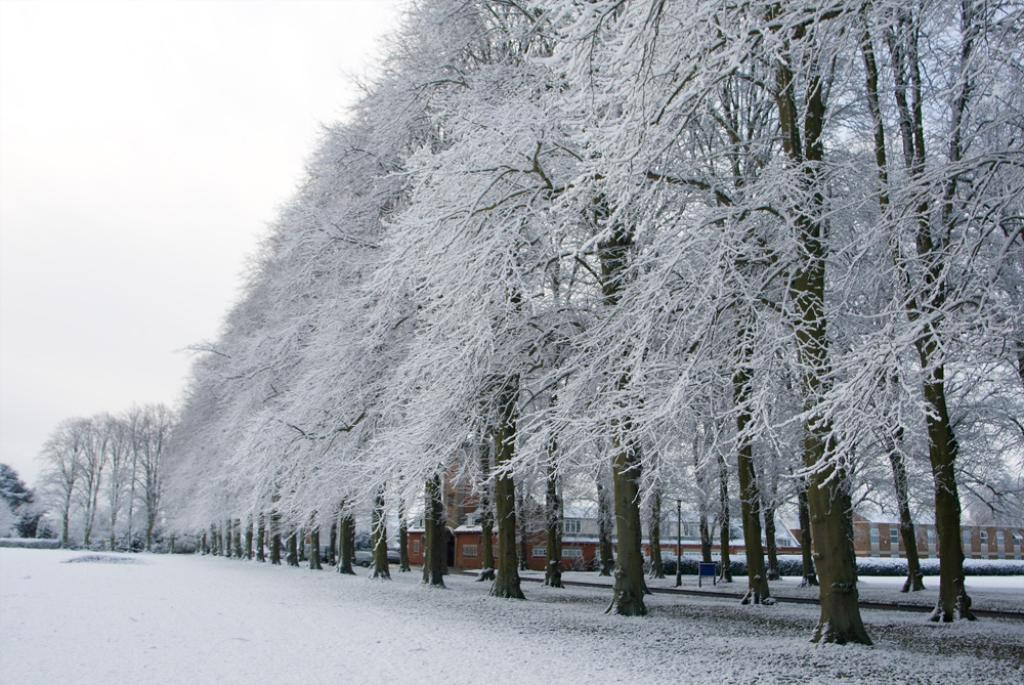What type of vegetation is present in the image? There are trees in the image. What is covering the ground in the image? There is snow in the image. What type of structures can be seen in the image? There are buildings with windows in the image. What else can be seen in the image besides trees and buildings? There are objects in the image. What color is the background of the image? The background of the image is white. Can you see a stick being used by the goat in the image? There is no goat or stick present in the image. What type of wire is connecting the buildings in the image? There is no wire connecting the buildings in the image; the buildings have windows. 